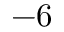Convert formula to latex. <formula><loc_0><loc_0><loc_500><loc_500>- 6</formula> 